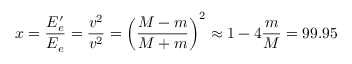Convert formula to latex. <formula><loc_0><loc_0><loc_500><loc_500>x = \frac { E _ { e } ^ { \prime } } { E _ { e } } = \frac { v ^ { 2 } } { v ^ { 2 } } = \left ( \frac { M - m } { M + m } \right ) ^ { 2 } \approx 1 - 4 \frac { m } { M } = 9 9 . 9 5 \, \</formula> 